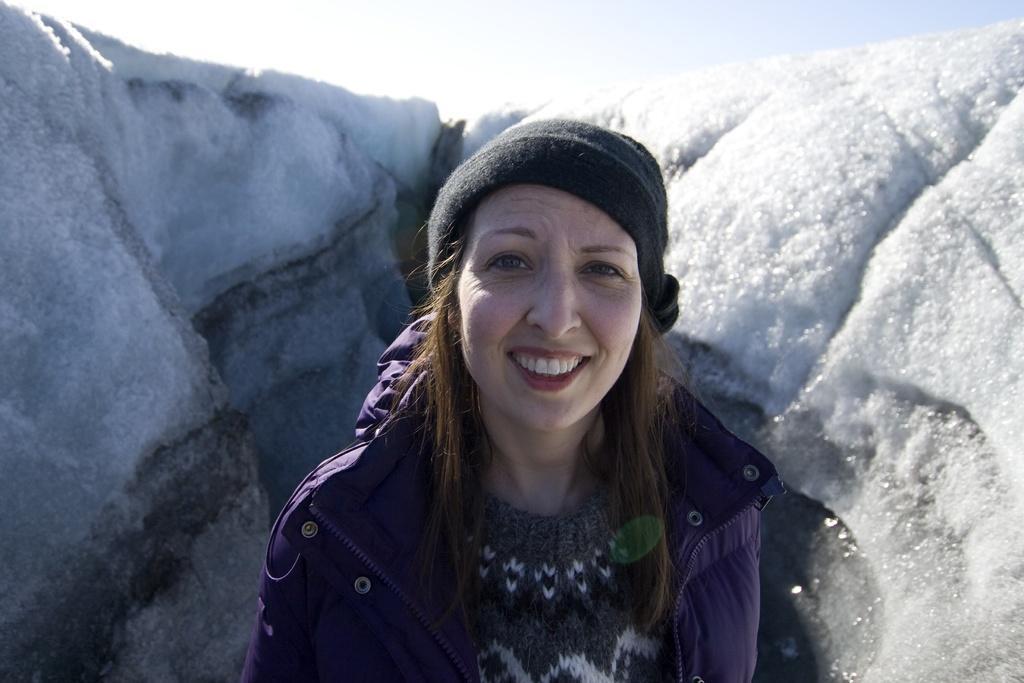Could you give a brief overview of what you see in this image? In this picture we can see a woman wore a cap, jacket and smiling and in the background we can see snow, sky. 